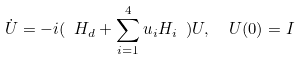<formula> <loc_0><loc_0><loc_500><loc_500>\dot { U } = - i ( \ H _ { d } + \sum _ { i = 1 } ^ { 4 } u _ { i } H _ { i } \ ) U , \ \ U ( 0 ) = I</formula> 